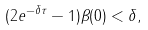Convert formula to latex. <formula><loc_0><loc_0><loc_500><loc_500>( 2 e ^ { - \delta \tau } - 1 ) \beta ( 0 ) < \delta ,</formula> 